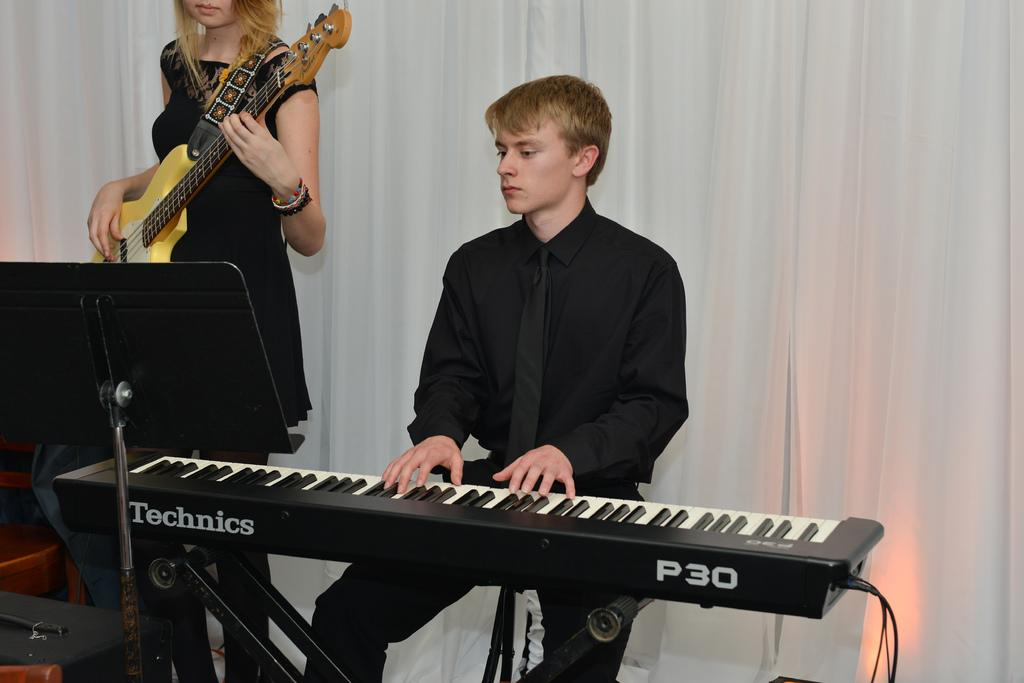What is the man in the image doing? The man is playing a musical instrument in the image. What is the woman in the image doing? The woman is also playing a musical instrument in the image. Can you describe the activity taking place in the image? The image features a man and a woman both playing musical instruments. What type of leather can be seen in the image? There is no leather present in the image. How many knots are tied in the image? There are no knots present in the image. 